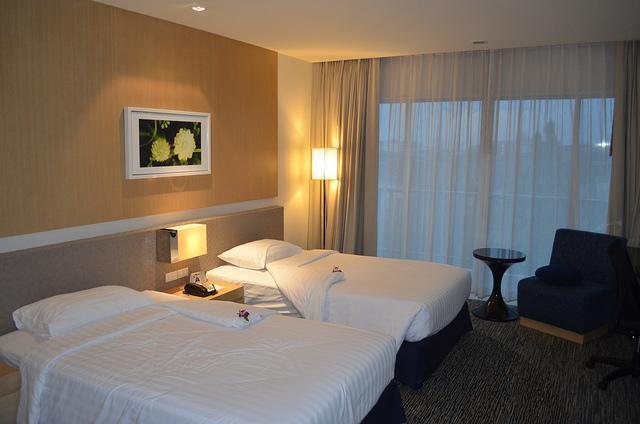How many beds?
Give a very brief answer. 2. How many beds are in the room?
Give a very brief answer. 2. How many pillows are there?
Give a very brief answer. 2. How many beds can be seen?
Give a very brief answer. 2. 